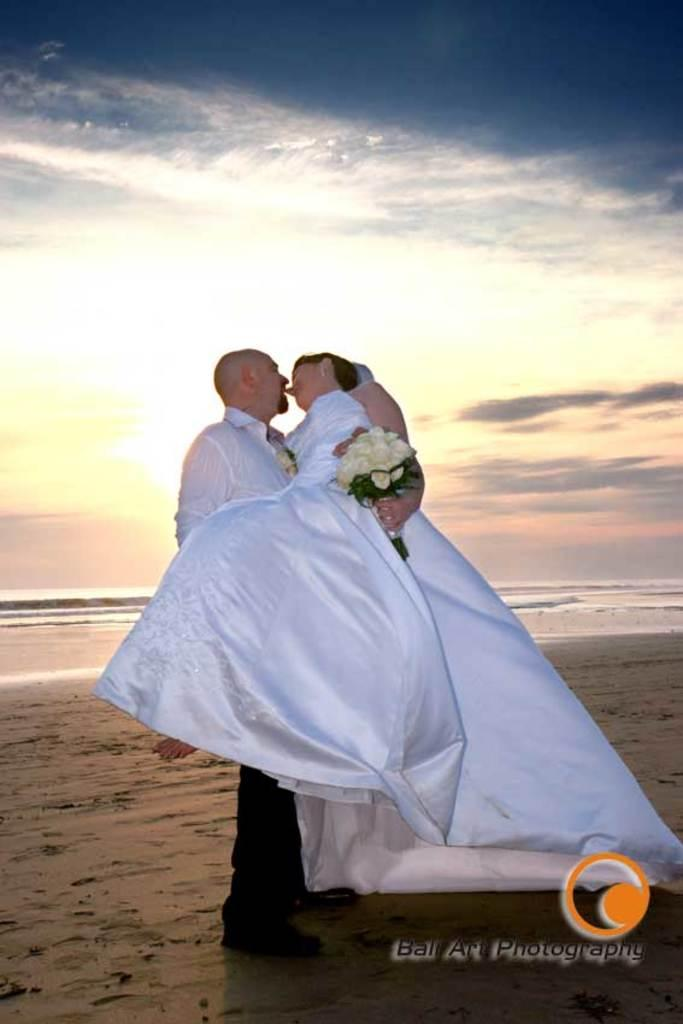What is happening between the two people in the image? There is a person standing and holding another person in the image. What can be seen in the background of the image? Water and the sky are visible in the background of the image. Is there any indication of the image's origin or ownership? Yes, there is a watermark on the image. What type of cake is being served during the volleyball game in the image? There is no cake or volleyball game present in the image. What government policies are being discussed in the image? There is no discussion of government policies in the image. 